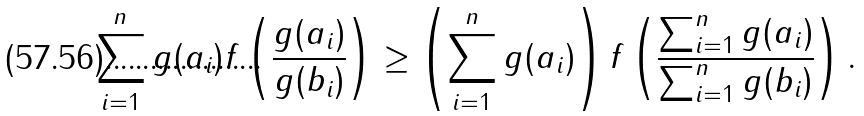<formula> <loc_0><loc_0><loc_500><loc_500>\sum _ { i = 1 } ^ { n } g ( a _ { i } ) f \left ( \frac { g ( a _ { i } ) } { g ( b _ { i } ) } \right ) \geq \left ( \sum _ { i = 1 } ^ { n } g ( a _ { i } ) \right ) f \left ( \frac { \sum _ { i = 1 } ^ { n } g ( a _ { i } ) } { \sum _ { i = 1 } ^ { n } g ( b _ { i } ) } \right ) .</formula> 